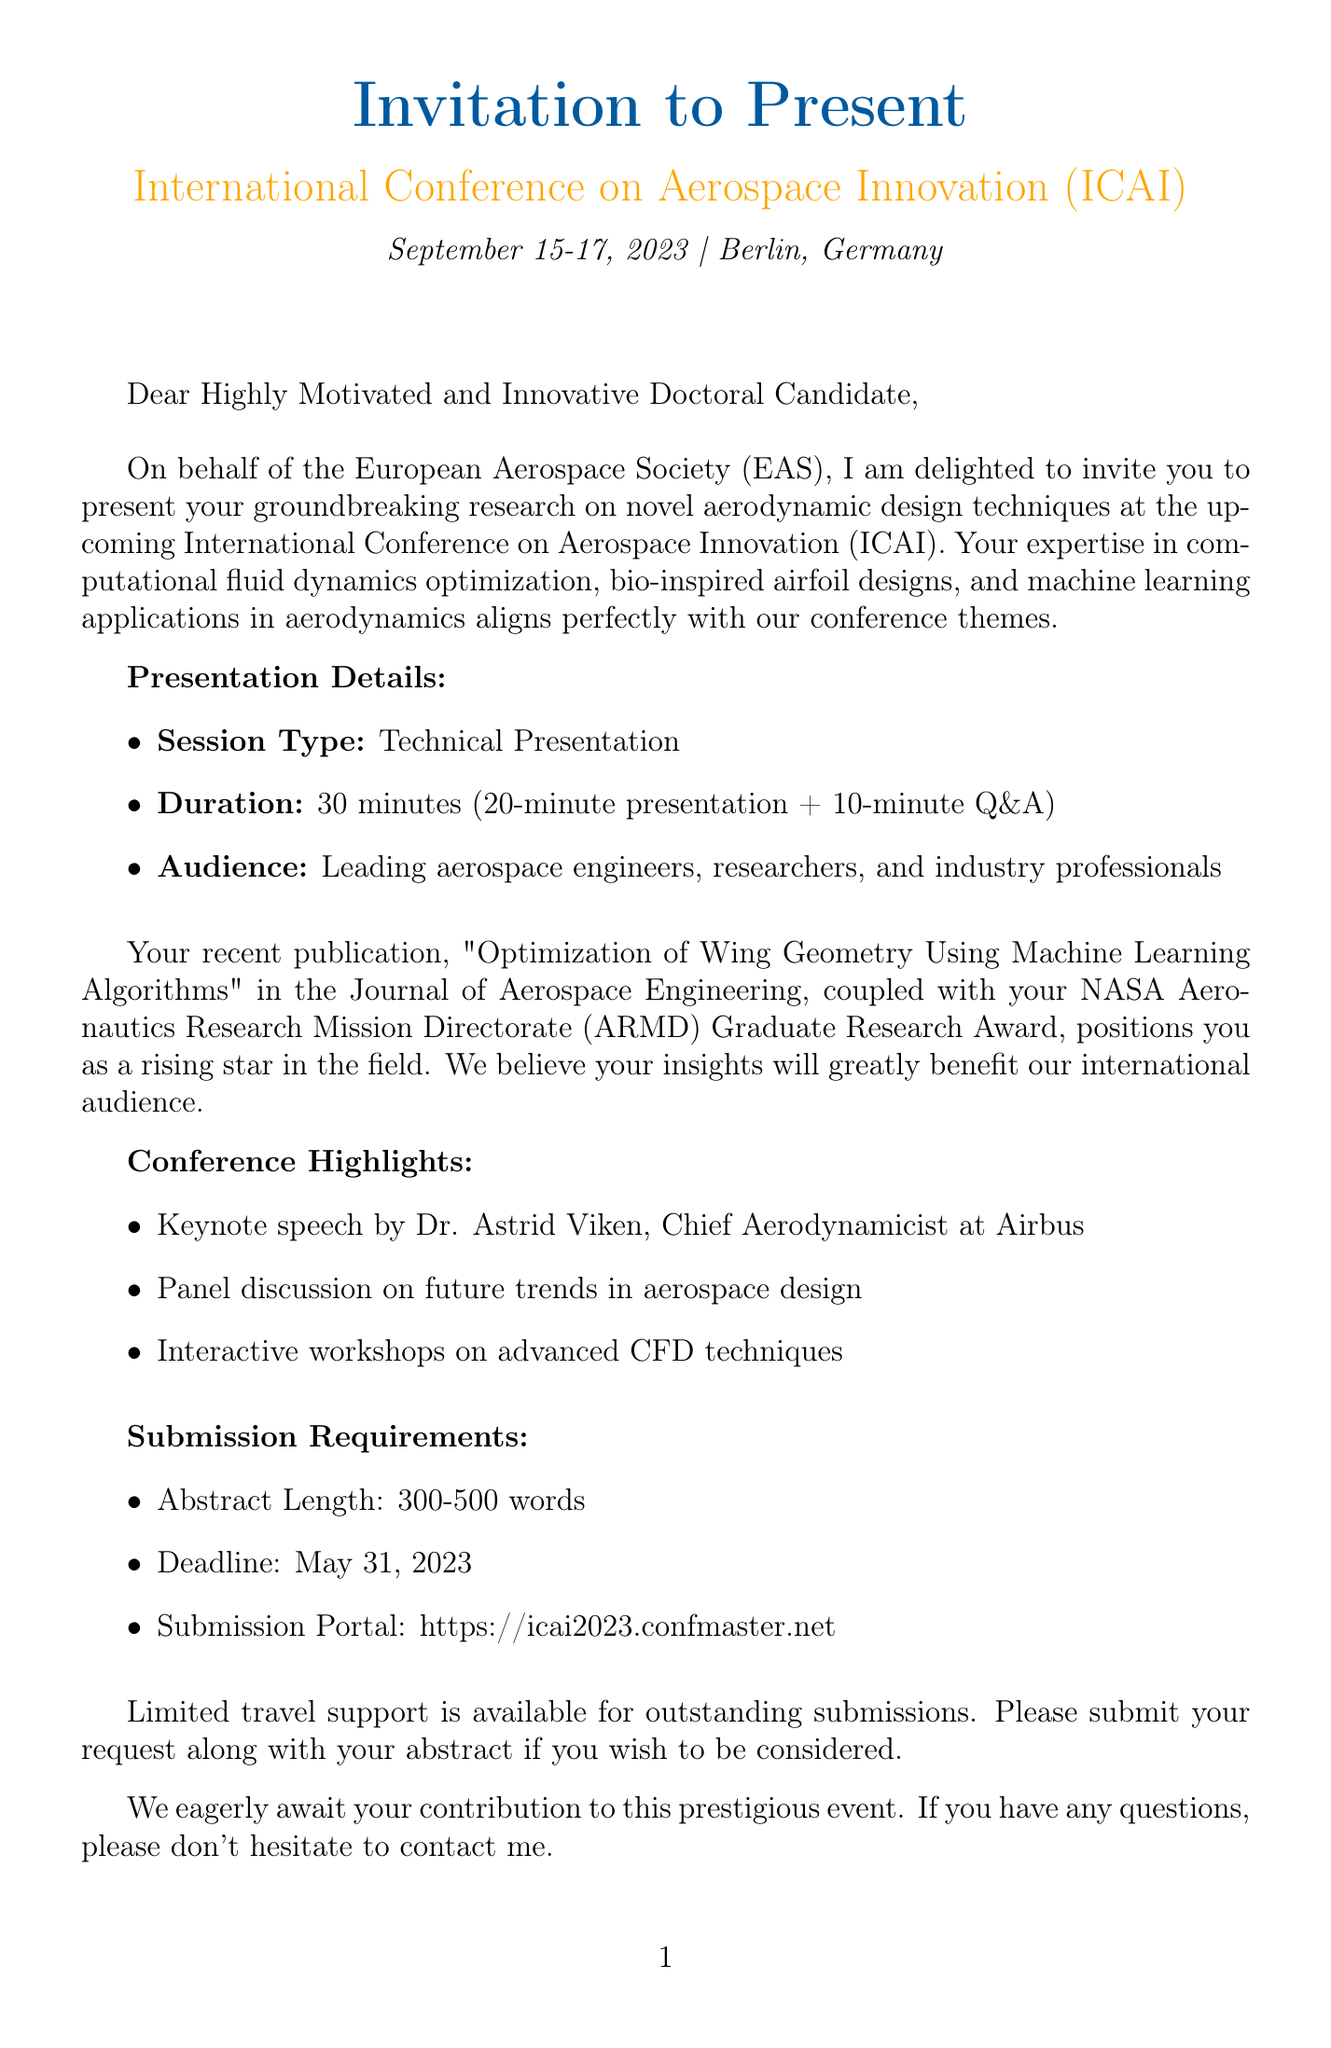What is the name of the conference? The conference is named "International Conference on Aerospace Innovation (ICAI)."
Answer: International Conference on Aerospace Innovation (ICAI) What are the dates of the conference? The conference dates are mentioned as September 15-17, 2023.
Answer: September 15-17, 2023 Who is the organizer of the conference? The organizer of the conference is the European Aerospace Society (EAS).
Answer: European Aerospace Society (EAS) What is the duration of the presentation? The document specifies that the presentation duration is 30 minutes.
Answer: 30 minutes What is the title of the recipient's recent publication? The title of the recent publication is "Optimization of Wing Geometry Using Machine Learning Algorithms."
Answer: Optimization of Wing Geometry Using Machine Learning Algorithms What is the deadline for abstract submission? The deadline for submission of the abstract is May 31, 2023.
Answer: May 31, 2023 Who is the contact person for the conference? The contact person mentioned in the document is Dr. Marcus Hoffman.
Answer: Dr. Marcus Hoffman What type of session is the presentation classified as? The presentation is classified as a Technical Presentation.
Answer: Technical Presentation What are the potential benefits of attending the conference? The potential benefits listed include networking with international experts, gaining feedback, exploring collaboration opportunities, and enhancing visibility.
Answer: Networking with international experts, gaining feedback on cutting-edge research, exploring collaboration opportunities with industry leaders, enhancing visibility in the aerospace community 